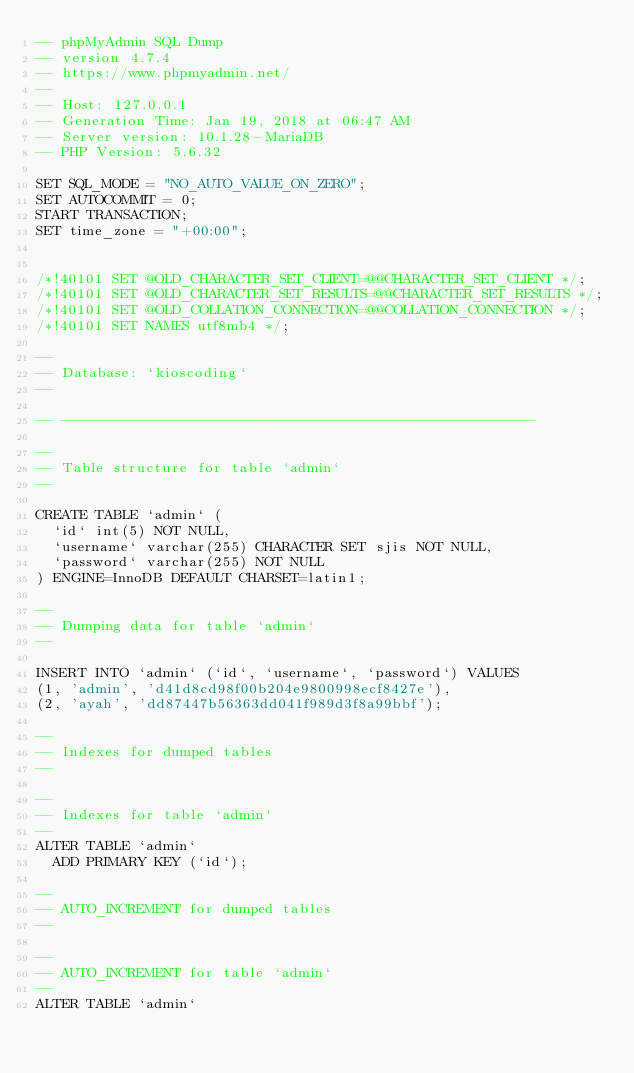Convert code to text. <code><loc_0><loc_0><loc_500><loc_500><_SQL_>-- phpMyAdmin SQL Dump
-- version 4.7.4
-- https://www.phpmyadmin.net/
--
-- Host: 127.0.0.1
-- Generation Time: Jan 19, 2018 at 06:47 AM
-- Server version: 10.1.28-MariaDB
-- PHP Version: 5.6.32

SET SQL_MODE = "NO_AUTO_VALUE_ON_ZERO";
SET AUTOCOMMIT = 0;
START TRANSACTION;
SET time_zone = "+00:00";


/*!40101 SET @OLD_CHARACTER_SET_CLIENT=@@CHARACTER_SET_CLIENT */;
/*!40101 SET @OLD_CHARACTER_SET_RESULTS=@@CHARACTER_SET_RESULTS */;
/*!40101 SET @OLD_COLLATION_CONNECTION=@@COLLATION_CONNECTION */;
/*!40101 SET NAMES utf8mb4 */;

--
-- Database: `kioscoding`
--

-- --------------------------------------------------------

--
-- Table structure for table `admin`
--

CREATE TABLE `admin` (
  `id` int(5) NOT NULL,
  `username` varchar(255) CHARACTER SET sjis NOT NULL,
  `password` varchar(255) NOT NULL
) ENGINE=InnoDB DEFAULT CHARSET=latin1;

--
-- Dumping data for table `admin`
--

INSERT INTO `admin` (`id`, `username`, `password`) VALUES
(1, 'admin', 'd41d8cd98f00b204e9800998ecf8427e'),
(2, 'ayah', 'dd87447b56363dd041f989d3f8a99bbf');

--
-- Indexes for dumped tables
--

--
-- Indexes for table `admin`
--
ALTER TABLE `admin`
  ADD PRIMARY KEY (`id`);

--
-- AUTO_INCREMENT for dumped tables
--

--
-- AUTO_INCREMENT for table `admin`
--
ALTER TABLE `admin`</code> 